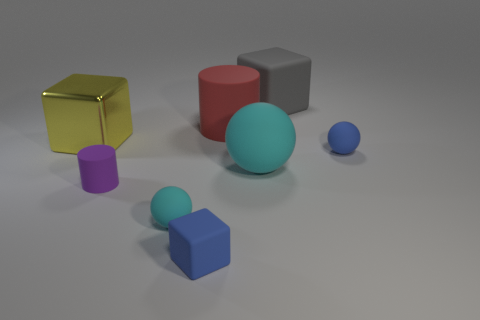What material is the cyan thing that is the same size as the yellow cube?
Keep it short and to the point. Rubber. Is there a blue metallic ball of the same size as the red matte object?
Provide a succinct answer. No. What is the shape of the cyan rubber thing that is the same size as the purple cylinder?
Give a very brief answer. Sphere. How many other objects are there of the same color as the large matte ball?
Provide a succinct answer. 1. There is a large object that is both in front of the large red object and to the right of the purple cylinder; what is its shape?
Your response must be concise. Sphere. There is a big matte object that is in front of the small sphere behind the tiny purple matte cylinder; is there a matte object that is in front of it?
Offer a terse response. Yes. How many other objects are the same material as the large cylinder?
Provide a succinct answer. 6. How many tiny spheres are there?
Offer a terse response. 2. How many things are either large yellow shiny balls or objects that are behind the blue matte sphere?
Keep it short and to the point. 3. Are there any other things that have the same shape as the big red thing?
Provide a short and direct response. Yes. 